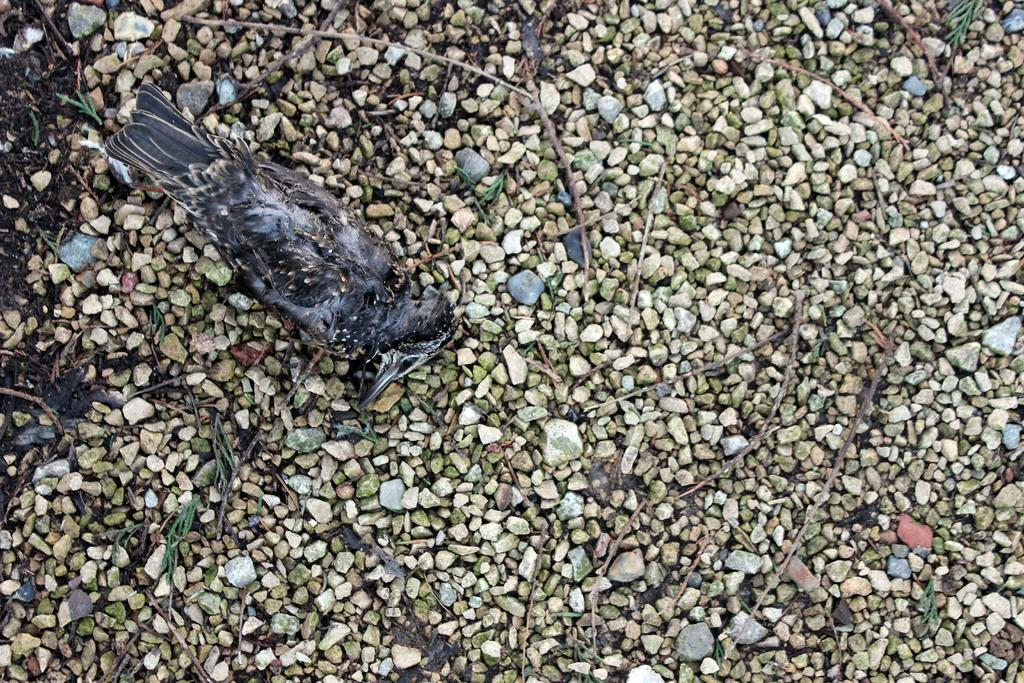What type of animal is in the image? There is a bird in the image. Can you describe the bird's coloring? The bird has black and gray colors. What else can be seen in the image besides the bird? There are stones visible in the image. What statement does the bird make in the image? There is no indication in the image that the bird is making a statement. 